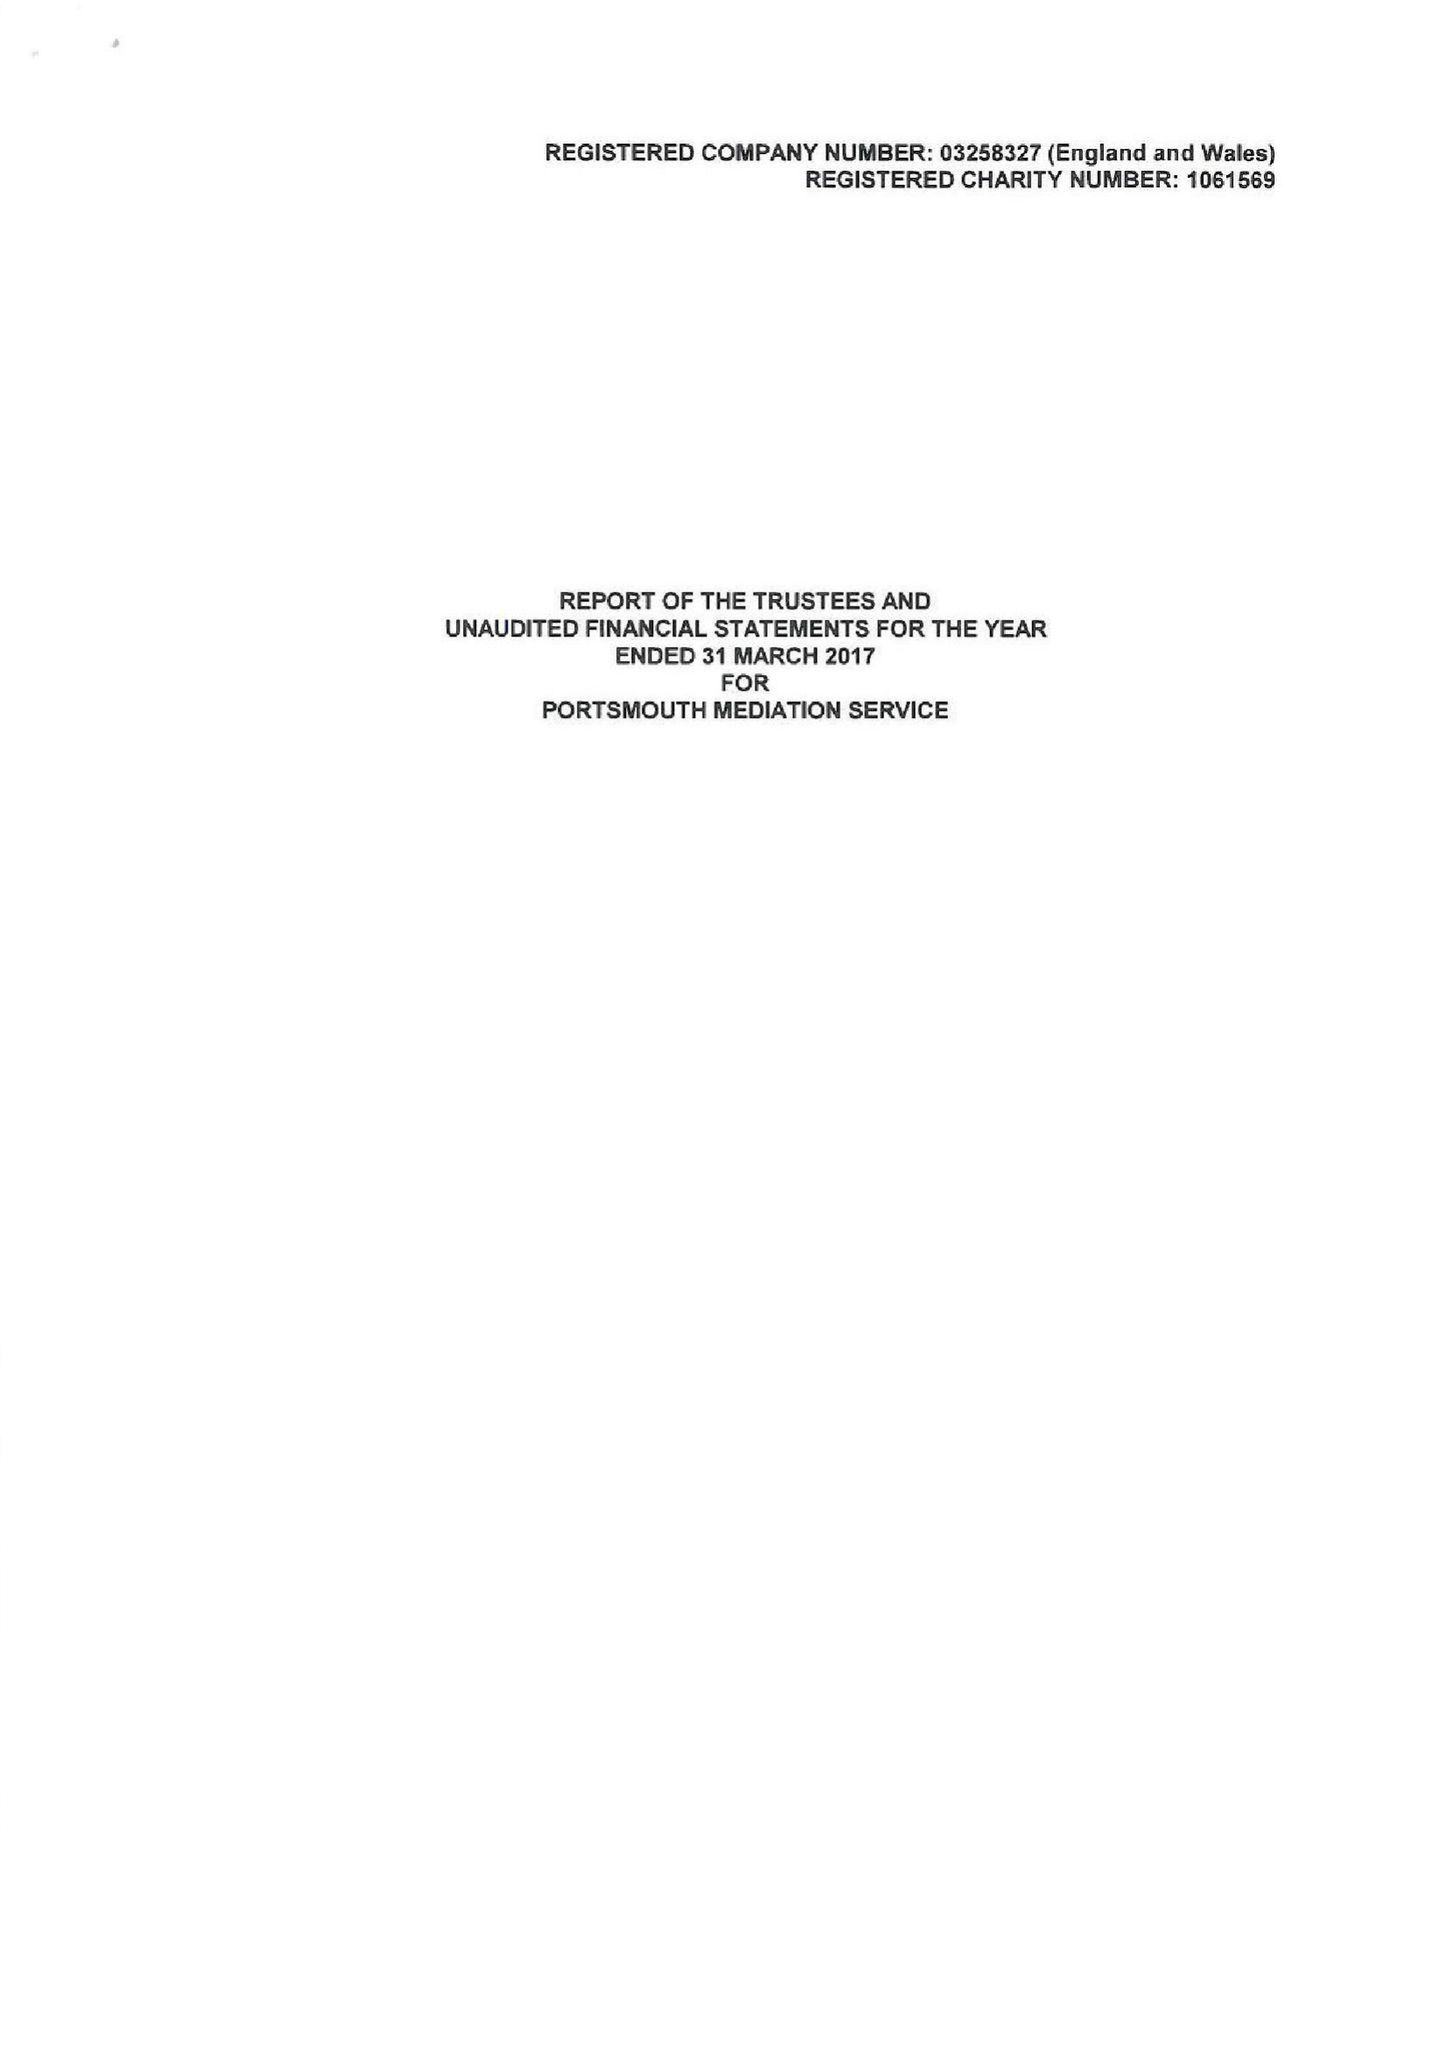What is the value for the address__street_line?
Answer the question using a single word or phrase. ARUNDEL STREET 